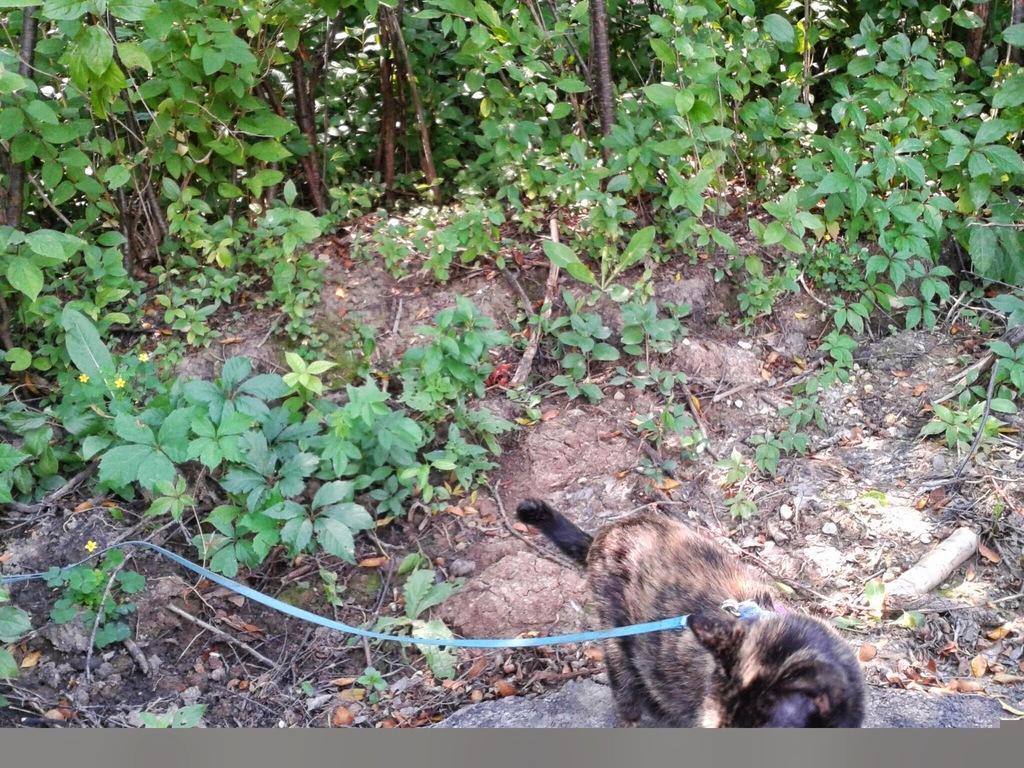Could you give a brief overview of what you see in this image? There is an animal present at the bottom of this image. We can see plants in the background. 